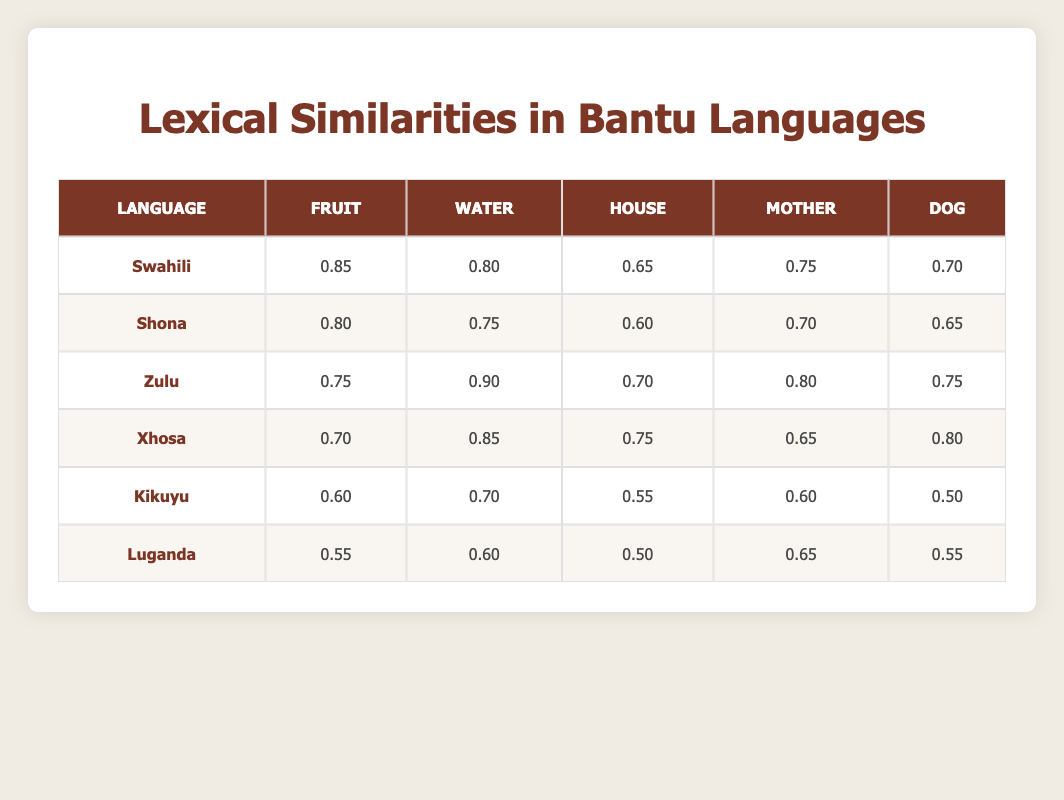What is the highest lexical similarity for the word "fruit"? Swahili has the highest similarity score for the word "fruit" at 0.85. The table shows the scores for "fruit" across all languages, and Swahili's score is the largest.
Answer: 0.85 Which language shows the lowest similarity for the word "water"? Luganda has the lowest similarity score for the word "water" at 0.60. By comparing the scores for "water" across all languages in the table, Luganda is the one with the smallest value.
Answer: 0.60 What is the average lexical similarity for the word "mother"? To find the average similarity for "mother," we add the scores: 0.75 (Swahili) + 0.70 (Shona) + 0.80 (Zulu) + 0.65 (Xhosa) + 0.60 (Kikuyu) + 0.65 (Luganda) = 4.25. Then, we divide this by 6 (the number of languages), which results in an average of approximately 0.71.
Answer: 0.71 Does KiKuyu have a higher score for "house" than Shona? Kikuyu has a score of 0.55 for "house," while Shona's score is 0.60. Comparing these values, Kikuyu does not have a higher score than Shona. Therefore, the statement is false.
Answer: False Which language or languages have a higher similarity for "dog" compared to Xhosa? Xhosa has a similarity score of 0.80 for "dog." By examining the scores for "dog," both Zulu (0.75) and Shona (0.65) have lower scores, while Swahili (0.70) is also lower than Xhosa. Kikuyu and Luganda also score lower. Thus, there are no languages with higher similarity than Xhosa for the word "dog."
Answer: None 